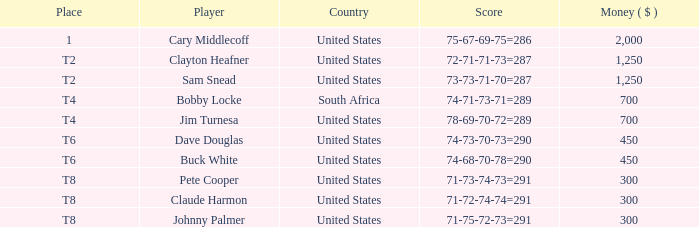What is Claude Harmon's Place? T8. 